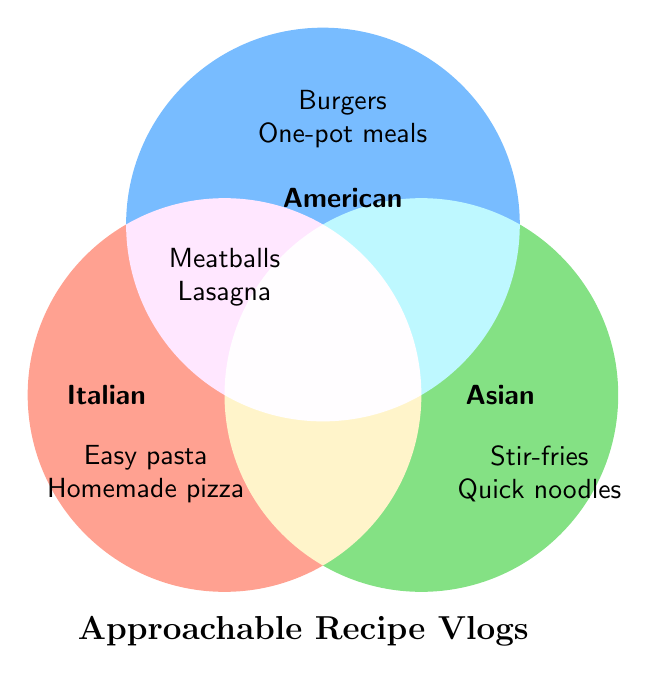What are the names of the cuisines featured in the vlogs? The figure shows three circles with labels identifying the types of cuisines.
Answer: Italian, American, Asian What types of dishes are listed under the American cuisine? The section labeled "American" lists the types of dishes included under that category.
Answer: Burgers, One-pot meals Which section lists "Meatballs" and "Lasagna"? The central overlapping section between "Italian" and "American" lists these dishes.
Answer: Italian+American What Italian dishes can be found in these vlogs? The Italian section lists the dishes under the "Italian" label.
Answer: Easy pasta, Homemade pizza Which cuisine categories do stir-fries and quick noodle dishes belong to? These dishes are listed under the section labeled "Asian."
Answer: Asian 